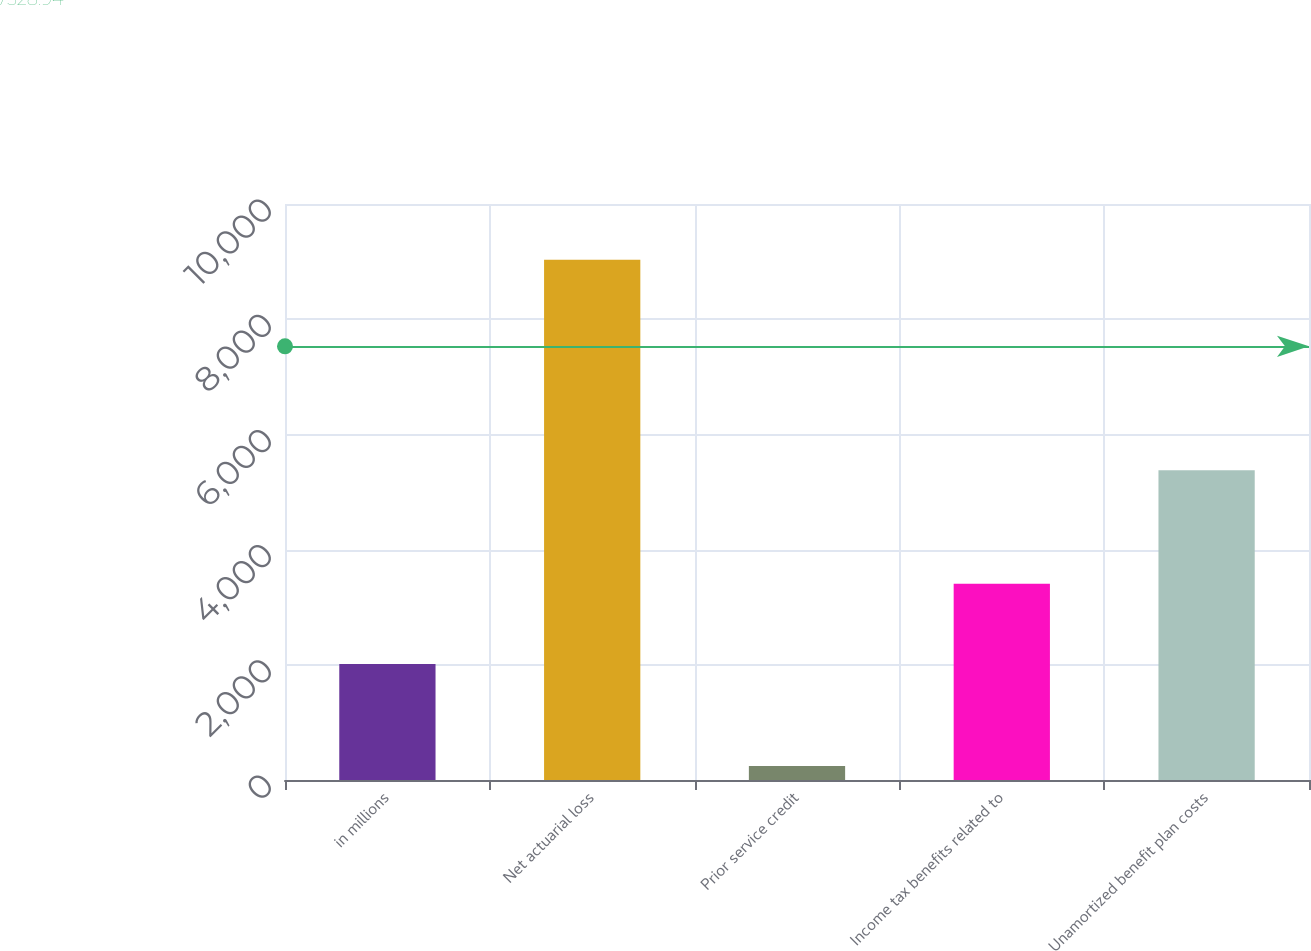Convert chart to OTSL. <chart><loc_0><loc_0><loc_500><loc_500><bar_chart><fcel>in millions<fcel>Net actuarial loss<fcel>Prior service credit<fcel>Income tax benefits related to<fcel>Unamortized benefit plan costs<nl><fcel>2016<fcel>9030<fcel>244<fcel>3407<fcel>5379<nl></chart> 